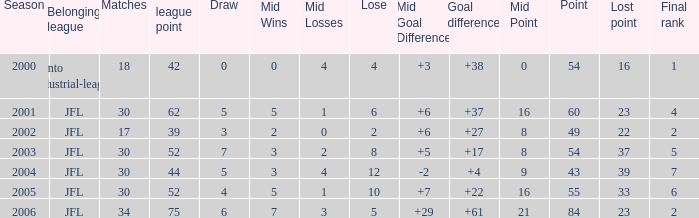Reveal the maximum matches for point 43 and last standing less than None. 